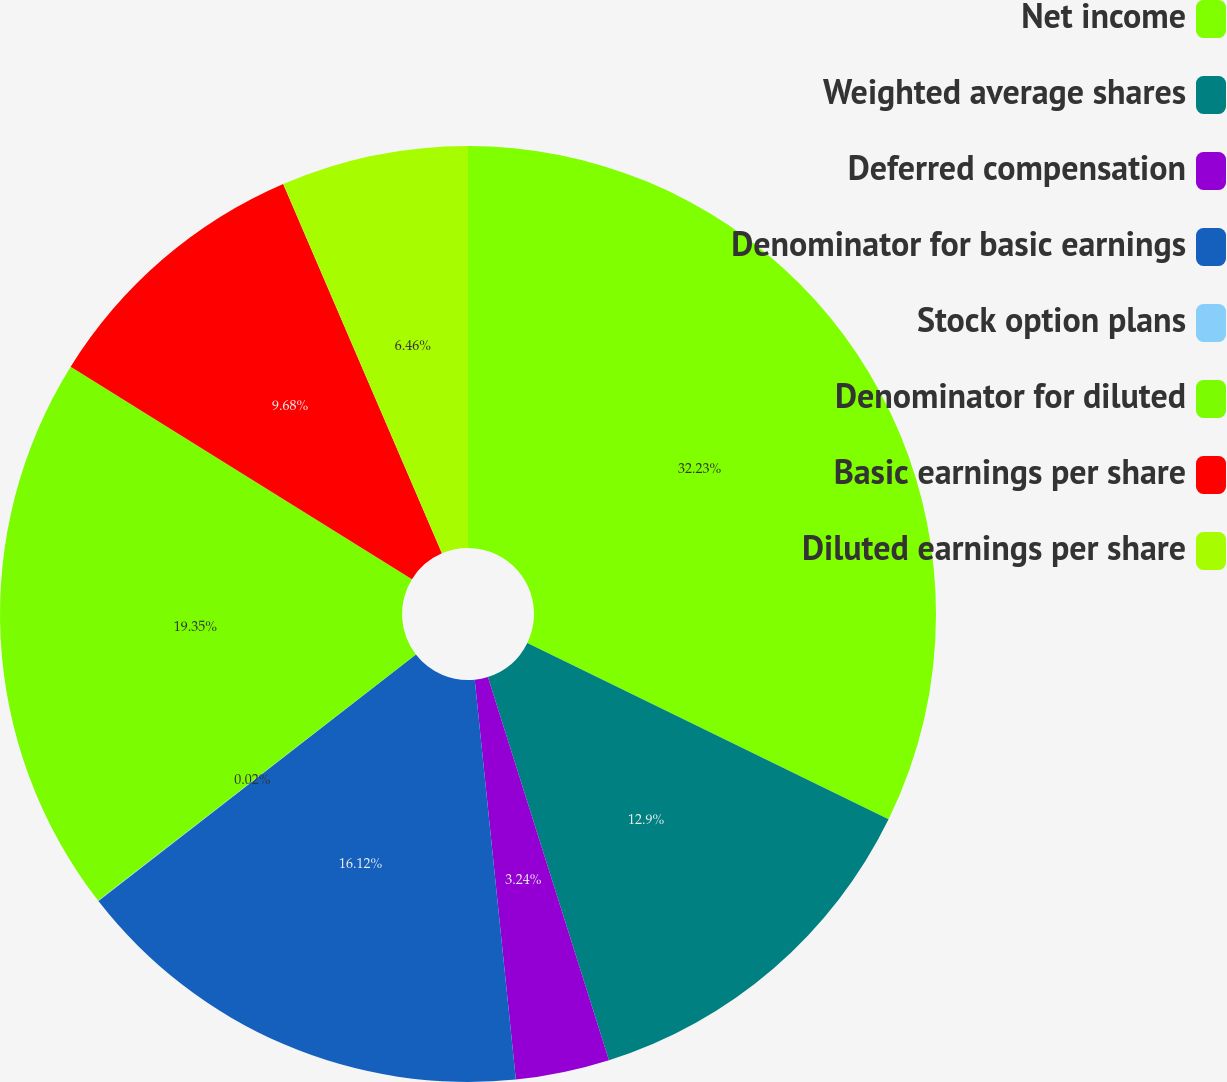Convert chart to OTSL. <chart><loc_0><loc_0><loc_500><loc_500><pie_chart><fcel>Net income<fcel>Weighted average shares<fcel>Deferred compensation<fcel>Denominator for basic earnings<fcel>Stock option plans<fcel>Denominator for diluted<fcel>Basic earnings per share<fcel>Diluted earnings per share<nl><fcel>32.23%<fcel>12.9%<fcel>3.24%<fcel>16.12%<fcel>0.02%<fcel>19.35%<fcel>9.68%<fcel>6.46%<nl></chart> 